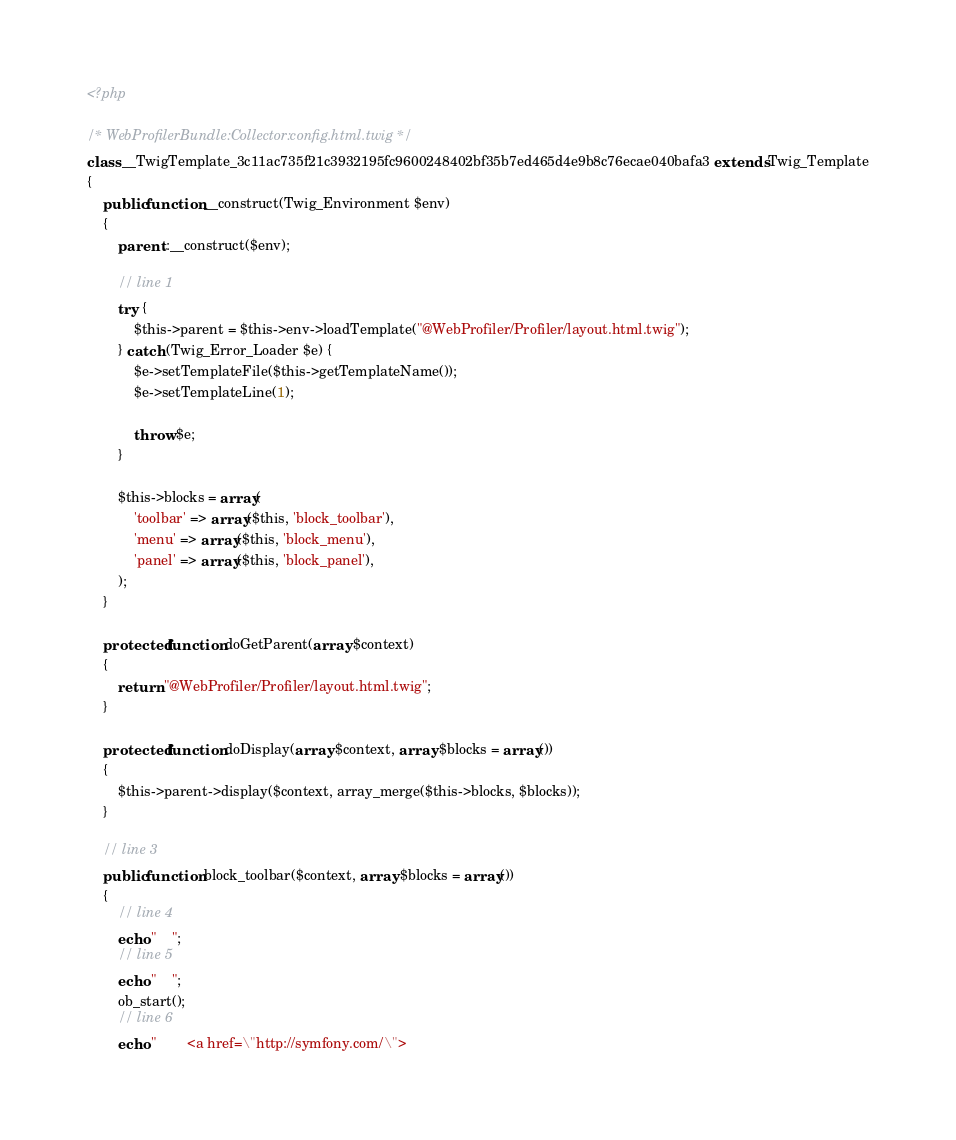<code> <loc_0><loc_0><loc_500><loc_500><_PHP_><?php

/* WebProfilerBundle:Collector:config.html.twig */
class __TwigTemplate_3c11ac735f21c3932195fc9600248402bf35b7ed465d4e9b8c76ecae040bafa3 extends Twig_Template
{
    public function __construct(Twig_Environment $env)
    {
        parent::__construct($env);

        // line 1
        try {
            $this->parent = $this->env->loadTemplate("@WebProfiler/Profiler/layout.html.twig");
        } catch (Twig_Error_Loader $e) {
            $e->setTemplateFile($this->getTemplateName());
            $e->setTemplateLine(1);

            throw $e;
        }

        $this->blocks = array(
            'toolbar' => array($this, 'block_toolbar'),
            'menu' => array($this, 'block_menu'),
            'panel' => array($this, 'block_panel'),
        );
    }

    protected function doGetParent(array $context)
    {
        return "@WebProfiler/Profiler/layout.html.twig";
    }

    protected function doDisplay(array $context, array $blocks = array())
    {
        $this->parent->display($context, array_merge($this->blocks, $blocks));
    }

    // line 3
    public function block_toolbar($context, array $blocks = array())
    {
        // line 4
        echo "    ";
        // line 5
        echo "    ";
        ob_start();
        // line 6
        echo "        <a href=\"http://symfony.com/\"></code> 